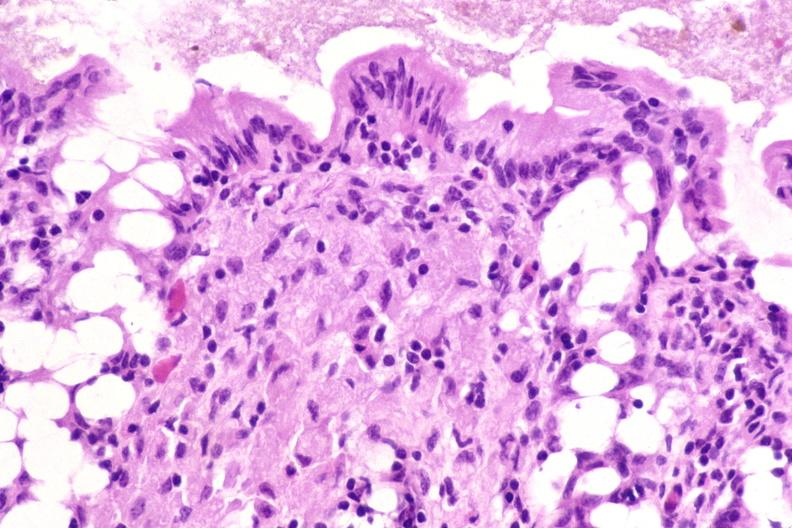how do colon biopsy , mycobacterium avium-intracellularae , stain?
Answer the question using a single word or phrase. Acid 